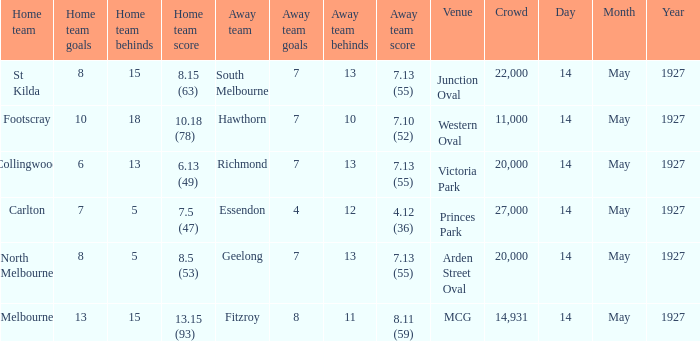Which away team had a score of 7.13 (55) against the home team North Melbourne? Geelong. 